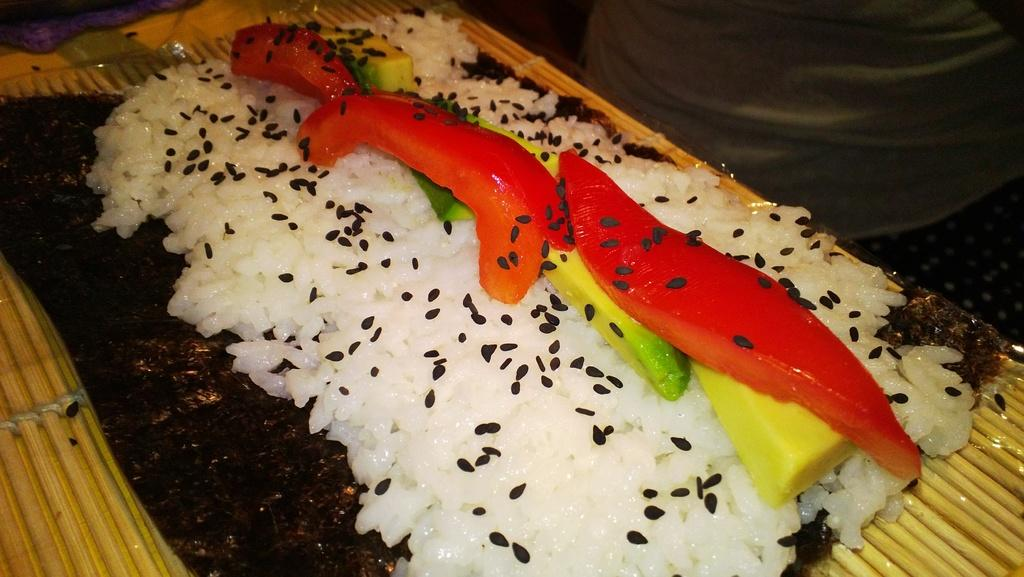What type of surface is visible in the image? There is a wooden mat in the image. What is placed on the wooden mat? There is a food item on the wooden mat. What are the main ingredients of the food item? The food item contains rice and sesame seeds. Are there any other ingredients or elements in the food item? Yes, there are other items in the food item. What type of news can be seen on the wooden mat in the image? There is no news present on the wooden mat in the image; it contains a food item. Is there a scarf visible on the wooden mat in the image? There is no scarf present on the wooden mat in the image; it contains a food item. 